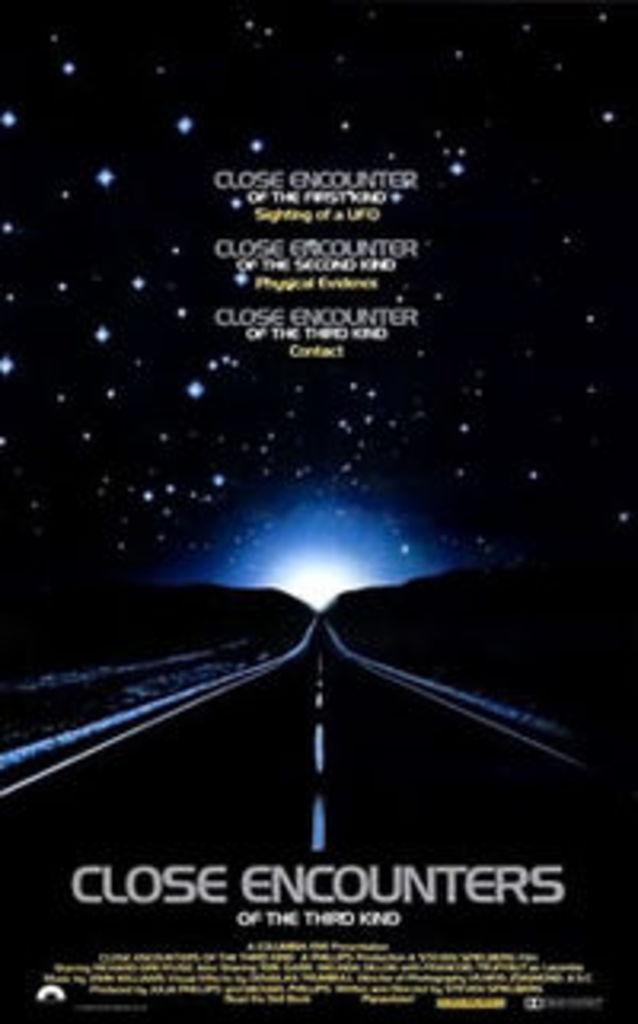<image>
Provide a brief description of the given image. A dark road at night heading towards a close encounter. 